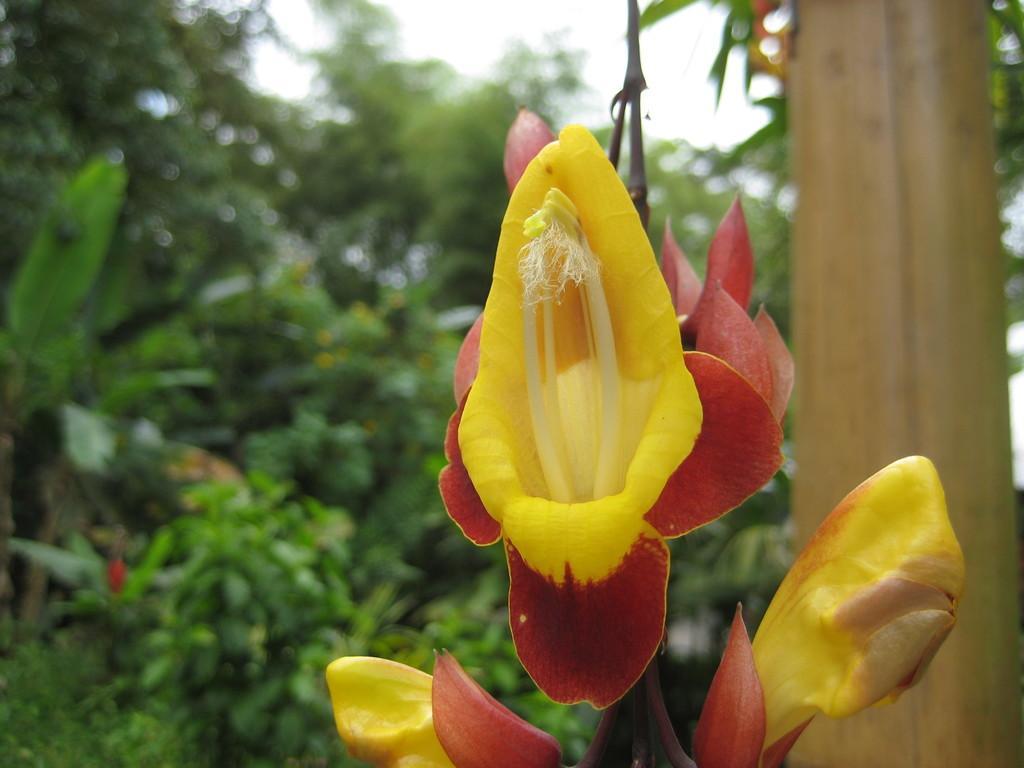How would you summarize this image in a sentence or two? In this picture I can see flowers in front, which are of yellow and red color. In the background I can see the trees and I see that it is totally blurred. On the right side of this picture I can see a brown color thing. 